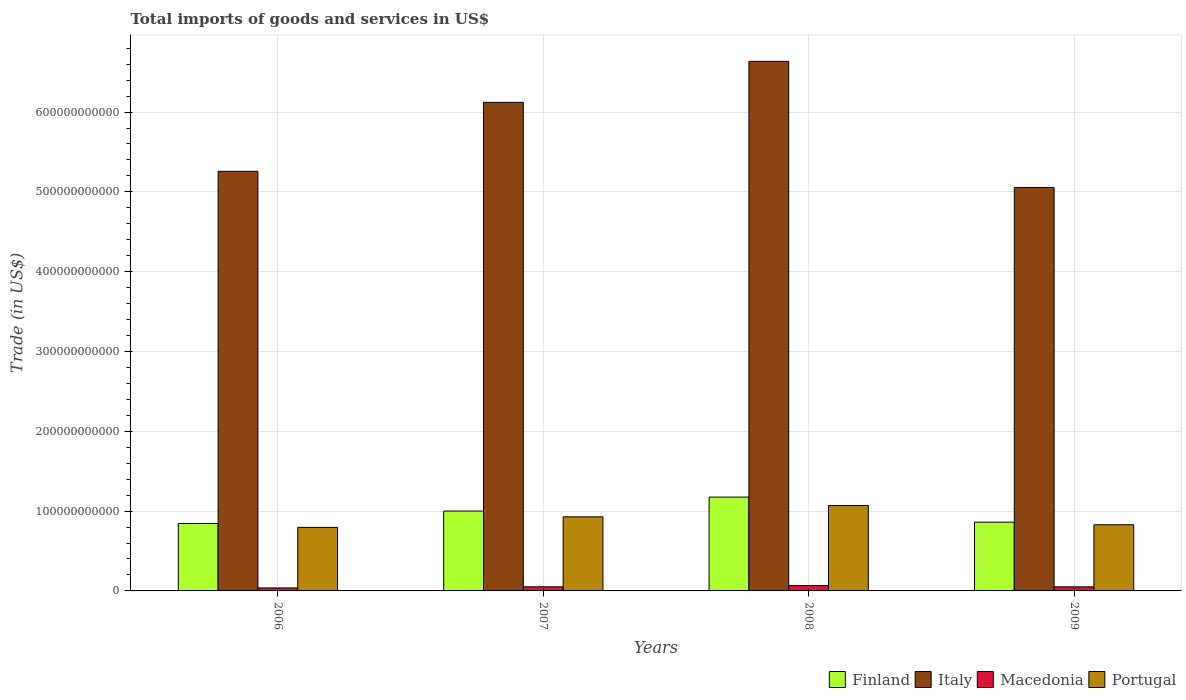How many groups of bars are there?
Keep it short and to the point. 4. Are the number of bars on each tick of the X-axis equal?
Your answer should be very brief. Yes. What is the label of the 3rd group of bars from the left?
Give a very brief answer. 2008. What is the total imports of goods and services in Portugal in 2008?
Keep it short and to the point. 1.07e+11. Across all years, what is the maximum total imports of goods and services in Italy?
Ensure brevity in your answer.  6.64e+11. Across all years, what is the minimum total imports of goods and services in Portugal?
Your response must be concise. 7.96e+1. In which year was the total imports of goods and services in Macedonia maximum?
Your response must be concise. 2008. In which year was the total imports of goods and services in Italy minimum?
Give a very brief answer. 2009. What is the total total imports of goods and services in Macedonia in the graph?
Offer a terse response. 2.08e+1. What is the difference between the total imports of goods and services in Italy in 2007 and that in 2008?
Offer a terse response. -5.14e+1. What is the difference between the total imports of goods and services in Macedonia in 2007 and the total imports of goods and services in Italy in 2006?
Your answer should be very brief. -5.21e+11. What is the average total imports of goods and services in Italy per year?
Ensure brevity in your answer.  5.77e+11. In the year 2006, what is the difference between the total imports of goods and services in Portugal and total imports of goods and services in Italy?
Your response must be concise. -4.46e+11. What is the ratio of the total imports of goods and services in Finland in 2007 to that in 2008?
Ensure brevity in your answer.  0.85. Is the total imports of goods and services in Portugal in 2006 less than that in 2007?
Make the answer very short. Yes. What is the difference between the highest and the second highest total imports of goods and services in Portugal?
Your response must be concise. 1.42e+1. What is the difference between the highest and the lowest total imports of goods and services in Macedonia?
Your answer should be very brief. 3.02e+09. What does the 2nd bar from the left in 2008 represents?
Give a very brief answer. Italy. What does the 2nd bar from the right in 2006 represents?
Provide a short and direct response. Macedonia. Are all the bars in the graph horizontal?
Ensure brevity in your answer.  No. How many years are there in the graph?
Ensure brevity in your answer.  4. What is the difference between two consecutive major ticks on the Y-axis?
Your answer should be very brief. 1.00e+11. Does the graph contain any zero values?
Your answer should be compact. No. Does the graph contain grids?
Your answer should be compact. Yes. Where does the legend appear in the graph?
Make the answer very short. Bottom right. What is the title of the graph?
Offer a terse response. Total imports of goods and services in US$. What is the label or title of the Y-axis?
Your answer should be compact. Trade (in US$). What is the Trade (in US$) in Finland in 2006?
Your answer should be very brief. 8.45e+1. What is the Trade (in US$) in Italy in 2006?
Your response must be concise. 5.26e+11. What is the Trade (in US$) in Macedonia in 2006?
Offer a very short reply. 3.76e+09. What is the Trade (in US$) of Portugal in 2006?
Your answer should be very brief. 7.96e+1. What is the Trade (in US$) of Finland in 2007?
Offer a terse response. 1.00e+11. What is the Trade (in US$) of Italy in 2007?
Your answer should be compact. 6.12e+11. What is the Trade (in US$) in Macedonia in 2007?
Offer a terse response. 5.17e+09. What is the Trade (in US$) of Portugal in 2007?
Ensure brevity in your answer.  9.28e+1. What is the Trade (in US$) in Finland in 2008?
Your response must be concise. 1.18e+11. What is the Trade (in US$) of Italy in 2008?
Make the answer very short. 6.64e+11. What is the Trade (in US$) in Macedonia in 2008?
Provide a succinct answer. 6.77e+09. What is the Trade (in US$) in Portugal in 2008?
Make the answer very short. 1.07e+11. What is the Trade (in US$) of Finland in 2009?
Offer a terse response. 8.62e+1. What is the Trade (in US$) of Italy in 2009?
Keep it short and to the point. 5.05e+11. What is the Trade (in US$) in Macedonia in 2009?
Make the answer very short. 5.11e+09. What is the Trade (in US$) of Portugal in 2009?
Your answer should be compact. 8.29e+1. Across all years, what is the maximum Trade (in US$) of Finland?
Keep it short and to the point. 1.18e+11. Across all years, what is the maximum Trade (in US$) of Italy?
Provide a short and direct response. 6.64e+11. Across all years, what is the maximum Trade (in US$) in Macedonia?
Provide a short and direct response. 6.77e+09. Across all years, what is the maximum Trade (in US$) in Portugal?
Your response must be concise. 1.07e+11. Across all years, what is the minimum Trade (in US$) in Finland?
Give a very brief answer. 8.45e+1. Across all years, what is the minimum Trade (in US$) of Italy?
Your answer should be compact. 5.05e+11. Across all years, what is the minimum Trade (in US$) in Macedonia?
Your answer should be very brief. 3.76e+09. Across all years, what is the minimum Trade (in US$) in Portugal?
Provide a short and direct response. 7.96e+1. What is the total Trade (in US$) in Finland in the graph?
Provide a succinct answer. 3.88e+11. What is the total Trade (in US$) of Italy in the graph?
Make the answer very short. 2.31e+12. What is the total Trade (in US$) of Macedonia in the graph?
Your answer should be very brief. 2.08e+1. What is the total Trade (in US$) in Portugal in the graph?
Offer a very short reply. 3.62e+11. What is the difference between the Trade (in US$) in Finland in 2006 and that in 2007?
Offer a very short reply. -1.56e+1. What is the difference between the Trade (in US$) of Italy in 2006 and that in 2007?
Your response must be concise. -8.64e+1. What is the difference between the Trade (in US$) of Macedonia in 2006 and that in 2007?
Keep it short and to the point. -1.41e+09. What is the difference between the Trade (in US$) of Portugal in 2006 and that in 2007?
Give a very brief answer. -1.32e+1. What is the difference between the Trade (in US$) in Finland in 2006 and that in 2008?
Offer a very short reply. -3.31e+1. What is the difference between the Trade (in US$) in Italy in 2006 and that in 2008?
Make the answer very short. -1.38e+11. What is the difference between the Trade (in US$) of Macedonia in 2006 and that in 2008?
Your response must be concise. -3.02e+09. What is the difference between the Trade (in US$) of Portugal in 2006 and that in 2008?
Your answer should be compact. -2.74e+1. What is the difference between the Trade (in US$) in Finland in 2006 and that in 2009?
Your answer should be very brief. -1.68e+09. What is the difference between the Trade (in US$) of Italy in 2006 and that in 2009?
Your answer should be compact. 2.03e+1. What is the difference between the Trade (in US$) of Macedonia in 2006 and that in 2009?
Ensure brevity in your answer.  -1.35e+09. What is the difference between the Trade (in US$) of Portugal in 2006 and that in 2009?
Provide a succinct answer. -3.30e+09. What is the difference between the Trade (in US$) in Finland in 2007 and that in 2008?
Make the answer very short. -1.75e+1. What is the difference between the Trade (in US$) of Italy in 2007 and that in 2008?
Offer a terse response. -5.14e+1. What is the difference between the Trade (in US$) in Macedonia in 2007 and that in 2008?
Make the answer very short. -1.61e+09. What is the difference between the Trade (in US$) in Portugal in 2007 and that in 2008?
Your response must be concise. -1.42e+1. What is the difference between the Trade (in US$) in Finland in 2007 and that in 2009?
Your response must be concise. 1.39e+1. What is the difference between the Trade (in US$) in Italy in 2007 and that in 2009?
Provide a short and direct response. 1.07e+11. What is the difference between the Trade (in US$) in Macedonia in 2007 and that in 2009?
Offer a very short reply. 5.48e+07. What is the difference between the Trade (in US$) in Portugal in 2007 and that in 2009?
Your answer should be compact. 9.94e+09. What is the difference between the Trade (in US$) in Finland in 2008 and that in 2009?
Your answer should be very brief. 3.14e+1. What is the difference between the Trade (in US$) in Italy in 2008 and that in 2009?
Provide a succinct answer. 1.58e+11. What is the difference between the Trade (in US$) in Macedonia in 2008 and that in 2009?
Provide a succinct answer. 1.66e+09. What is the difference between the Trade (in US$) of Portugal in 2008 and that in 2009?
Keep it short and to the point. 2.41e+1. What is the difference between the Trade (in US$) of Finland in 2006 and the Trade (in US$) of Italy in 2007?
Offer a terse response. -5.28e+11. What is the difference between the Trade (in US$) in Finland in 2006 and the Trade (in US$) in Macedonia in 2007?
Provide a succinct answer. 7.93e+1. What is the difference between the Trade (in US$) in Finland in 2006 and the Trade (in US$) in Portugal in 2007?
Make the answer very short. -8.34e+09. What is the difference between the Trade (in US$) of Italy in 2006 and the Trade (in US$) of Macedonia in 2007?
Your answer should be compact. 5.21e+11. What is the difference between the Trade (in US$) in Italy in 2006 and the Trade (in US$) in Portugal in 2007?
Provide a short and direct response. 4.33e+11. What is the difference between the Trade (in US$) in Macedonia in 2006 and the Trade (in US$) in Portugal in 2007?
Your answer should be compact. -8.91e+1. What is the difference between the Trade (in US$) of Finland in 2006 and the Trade (in US$) of Italy in 2008?
Give a very brief answer. -5.79e+11. What is the difference between the Trade (in US$) of Finland in 2006 and the Trade (in US$) of Macedonia in 2008?
Ensure brevity in your answer.  7.77e+1. What is the difference between the Trade (in US$) in Finland in 2006 and the Trade (in US$) in Portugal in 2008?
Your answer should be very brief. -2.25e+1. What is the difference between the Trade (in US$) in Italy in 2006 and the Trade (in US$) in Macedonia in 2008?
Make the answer very short. 5.19e+11. What is the difference between the Trade (in US$) of Italy in 2006 and the Trade (in US$) of Portugal in 2008?
Give a very brief answer. 4.19e+11. What is the difference between the Trade (in US$) in Macedonia in 2006 and the Trade (in US$) in Portugal in 2008?
Your response must be concise. -1.03e+11. What is the difference between the Trade (in US$) of Finland in 2006 and the Trade (in US$) of Italy in 2009?
Provide a short and direct response. -4.21e+11. What is the difference between the Trade (in US$) of Finland in 2006 and the Trade (in US$) of Macedonia in 2009?
Your answer should be very brief. 7.94e+1. What is the difference between the Trade (in US$) of Finland in 2006 and the Trade (in US$) of Portugal in 2009?
Provide a short and direct response. 1.60e+09. What is the difference between the Trade (in US$) of Italy in 2006 and the Trade (in US$) of Macedonia in 2009?
Give a very brief answer. 5.21e+11. What is the difference between the Trade (in US$) of Italy in 2006 and the Trade (in US$) of Portugal in 2009?
Keep it short and to the point. 4.43e+11. What is the difference between the Trade (in US$) in Macedonia in 2006 and the Trade (in US$) in Portugal in 2009?
Offer a terse response. -7.91e+1. What is the difference between the Trade (in US$) of Finland in 2007 and the Trade (in US$) of Italy in 2008?
Make the answer very short. -5.63e+11. What is the difference between the Trade (in US$) in Finland in 2007 and the Trade (in US$) in Macedonia in 2008?
Give a very brief answer. 9.33e+1. What is the difference between the Trade (in US$) of Finland in 2007 and the Trade (in US$) of Portugal in 2008?
Provide a succinct answer. -6.94e+09. What is the difference between the Trade (in US$) in Italy in 2007 and the Trade (in US$) in Macedonia in 2008?
Offer a very short reply. 6.05e+11. What is the difference between the Trade (in US$) in Italy in 2007 and the Trade (in US$) in Portugal in 2008?
Offer a very short reply. 5.05e+11. What is the difference between the Trade (in US$) in Macedonia in 2007 and the Trade (in US$) in Portugal in 2008?
Offer a very short reply. -1.02e+11. What is the difference between the Trade (in US$) of Finland in 2007 and the Trade (in US$) of Italy in 2009?
Provide a succinct answer. -4.05e+11. What is the difference between the Trade (in US$) in Finland in 2007 and the Trade (in US$) in Macedonia in 2009?
Provide a short and direct response. 9.49e+1. What is the difference between the Trade (in US$) of Finland in 2007 and the Trade (in US$) of Portugal in 2009?
Offer a terse response. 1.72e+1. What is the difference between the Trade (in US$) in Italy in 2007 and the Trade (in US$) in Macedonia in 2009?
Make the answer very short. 6.07e+11. What is the difference between the Trade (in US$) in Italy in 2007 and the Trade (in US$) in Portugal in 2009?
Your answer should be very brief. 5.29e+11. What is the difference between the Trade (in US$) in Macedonia in 2007 and the Trade (in US$) in Portugal in 2009?
Give a very brief answer. -7.77e+1. What is the difference between the Trade (in US$) of Finland in 2008 and the Trade (in US$) of Italy in 2009?
Ensure brevity in your answer.  -3.88e+11. What is the difference between the Trade (in US$) in Finland in 2008 and the Trade (in US$) in Macedonia in 2009?
Provide a short and direct response. 1.12e+11. What is the difference between the Trade (in US$) in Finland in 2008 and the Trade (in US$) in Portugal in 2009?
Offer a very short reply. 3.47e+1. What is the difference between the Trade (in US$) of Italy in 2008 and the Trade (in US$) of Macedonia in 2009?
Your answer should be very brief. 6.58e+11. What is the difference between the Trade (in US$) of Italy in 2008 and the Trade (in US$) of Portugal in 2009?
Provide a succinct answer. 5.81e+11. What is the difference between the Trade (in US$) of Macedonia in 2008 and the Trade (in US$) of Portugal in 2009?
Provide a succinct answer. -7.61e+1. What is the average Trade (in US$) of Finland per year?
Make the answer very short. 9.71e+1. What is the average Trade (in US$) in Italy per year?
Your answer should be compact. 5.77e+11. What is the average Trade (in US$) of Macedonia per year?
Provide a succinct answer. 5.20e+09. What is the average Trade (in US$) of Portugal per year?
Offer a terse response. 9.06e+1. In the year 2006, what is the difference between the Trade (in US$) of Finland and Trade (in US$) of Italy?
Your answer should be very brief. -4.41e+11. In the year 2006, what is the difference between the Trade (in US$) in Finland and Trade (in US$) in Macedonia?
Your response must be concise. 8.07e+1. In the year 2006, what is the difference between the Trade (in US$) of Finland and Trade (in US$) of Portugal?
Provide a short and direct response. 4.90e+09. In the year 2006, what is the difference between the Trade (in US$) of Italy and Trade (in US$) of Macedonia?
Ensure brevity in your answer.  5.22e+11. In the year 2006, what is the difference between the Trade (in US$) in Italy and Trade (in US$) in Portugal?
Your answer should be compact. 4.46e+11. In the year 2006, what is the difference between the Trade (in US$) in Macedonia and Trade (in US$) in Portugal?
Offer a terse response. -7.58e+1. In the year 2007, what is the difference between the Trade (in US$) in Finland and Trade (in US$) in Italy?
Make the answer very short. -5.12e+11. In the year 2007, what is the difference between the Trade (in US$) in Finland and Trade (in US$) in Macedonia?
Keep it short and to the point. 9.49e+1. In the year 2007, what is the difference between the Trade (in US$) in Finland and Trade (in US$) in Portugal?
Your answer should be compact. 7.24e+09. In the year 2007, what is the difference between the Trade (in US$) of Italy and Trade (in US$) of Macedonia?
Offer a terse response. 6.07e+11. In the year 2007, what is the difference between the Trade (in US$) of Italy and Trade (in US$) of Portugal?
Make the answer very short. 5.19e+11. In the year 2007, what is the difference between the Trade (in US$) of Macedonia and Trade (in US$) of Portugal?
Keep it short and to the point. -8.77e+1. In the year 2008, what is the difference between the Trade (in US$) in Finland and Trade (in US$) in Italy?
Keep it short and to the point. -5.46e+11. In the year 2008, what is the difference between the Trade (in US$) of Finland and Trade (in US$) of Macedonia?
Offer a very short reply. 1.11e+11. In the year 2008, what is the difference between the Trade (in US$) in Finland and Trade (in US$) in Portugal?
Give a very brief answer. 1.06e+1. In the year 2008, what is the difference between the Trade (in US$) of Italy and Trade (in US$) of Macedonia?
Your response must be concise. 6.57e+11. In the year 2008, what is the difference between the Trade (in US$) in Italy and Trade (in US$) in Portugal?
Keep it short and to the point. 5.57e+11. In the year 2008, what is the difference between the Trade (in US$) in Macedonia and Trade (in US$) in Portugal?
Ensure brevity in your answer.  -1.00e+11. In the year 2009, what is the difference between the Trade (in US$) in Finland and Trade (in US$) in Italy?
Provide a succinct answer. -4.19e+11. In the year 2009, what is the difference between the Trade (in US$) in Finland and Trade (in US$) in Macedonia?
Make the answer very short. 8.11e+1. In the year 2009, what is the difference between the Trade (in US$) of Finland and Trade (in US$) of Portugal?
Offer a very short reply. 3.29e+09. In the year 2009, what is the difference between the Trade (in US$) in Italy and Trade (in US$) in Macedonia?
Keep it short and to the point. 5.00e+11. In the year 2009, what is the difference between the Trade (in US$) in Italy and Trade (in US$) in Portugal?
Your answer should be compact. 4.23e+11. In the year 2009, what is the difference between the Trade (in US$) of Macedonia and Trade (in US$) of Portugal?
Offer a terse response. -7.78e+1. What is the ratio of the Trade (in US$) in Finland in 2006 to that in 2007?
Provide a short and direct response. 0.84. What is the ratio of the Trade (in US$) of Italy in 2006 to that in 2007?
Your answer should be compact. 0.86. What is the ratio of the Trade (in US$) of Macedonia in 2006 to that in 2007?
Keep it short and to the point. 0.73. What is the ratio of the Trade (in US$) in Portugal in 2006 to that in 2007?
Offer a very short reply. 0.86. What is the ratio of the Trade (in US$) of Finland in 2006 to that in 2008?
Offer a terse response. 0.72. What is the ratio of the Trade (in US$) in Italy in 2006 to that in 2008?
Give a very brief answer. 0.79. What is the ratio of the Trade (in US$) in Macedonia in 2006 to that in 2008?
Make the answer very short. 0.55. What is the ratio of the Trade (in US$) of Portugal in 2006 to that in 2008?
Make the answer very short. 0.74. What is the ratio of the Trade (in US$) of Finland in 2006 to that in 2009?
Offer a terse response. 0.98. What is the ratio of the Trade (in US$) of Italy in 2006 to that in 2009?
Give a very brief answer. 1.04. What is the ratio of the Trade (in US$) of Macedonia in 2006 to that in 2009?
Give a very brief answer. 0.73. What is the ratio of the Trade (in US$) in Portugal in 2006 to that in 2009?
Your response must be concise. 0.96. What is the ratio of the Trade (in US$) of Finland in 2007 to that in 2008?
Make the answer very short. 0.85. What is the ratio of the Trade (in US$) in Italy in 2007 to that in 2008?
Offer a very short reply. 0.92. What is the ratio of the Trade (in US$) in Macedonia in 2007 to that in 2008?
Give a very brief answer. 0.76. What is the ratio of the Trade (in US$) of Portugal in 2007 to that in 2008?
Ensure brevity in your answer.  0.87. What is the ratio of the Trade (in US$) of Finland in 2007 to that in 2009?
Your answer should be very brief. 1.16. What is the ratio of the Trade (in US$) of Italy in 2007 to that in 2009?
Offer a very short reply. 1.21. What is the ratio of the Trade (in US$) in Macedonia in 2007 to that in 2009?
Your response must be concise. 1.01. What is the ratio of the Trade (in US$) in Portugal in 2007 to that in 2009?
Give a very brief answer. 1.12. What is the ratio of the Trade (in US$) of Finland in 2008 to that in 2009?
Give a very brief answer. 1.36. What is the ratio of the Trade (in US$) of Italy in 2008 to that in 2009?
Provide a short and direct response. 1.31. What is the ratio of the Trade (in US$) of Macedonia in 2008 to that in 2009?
Your response must be concise. 1.32. What is the ratio of the Trade (in US$) in Portugal in 2008 to that in 2009?
Offer a terse response. 1.29. What is the difference between the highest and the second highest Trade (in US$) in Finland?
Provide a short and direct response. 1.75e+1. What is the difference between the highest and the second highest Trade (in US$) in Italy?
Your answer should be compact. 5.14e+1. What is the difference between the highest and the second highest Trade (in US$) in Macedonia?
Your answer should be compact. 1.61e+09. What is the difference between the highest and the second highest Trade (in US$) of Portugal?
Offer a very short reply. 1.42e+1. What is the difference between the highest and the lowest Trade (in US$) of Finland?
Keep it short and to the point. 3.31e+1. What is the difference between the highest and the lowest Trade (in US$) of Italy?
Your response must be concise. 1.58e+11. What is the difference between the highest and the lowest Trade (in US$) in Macedonia?
Give a very brief answer. 3.02e+09. What is the difference between the highest and the lowest Trade (in US$) of Portugal?
Make the answer very short. 2.74e+1. 